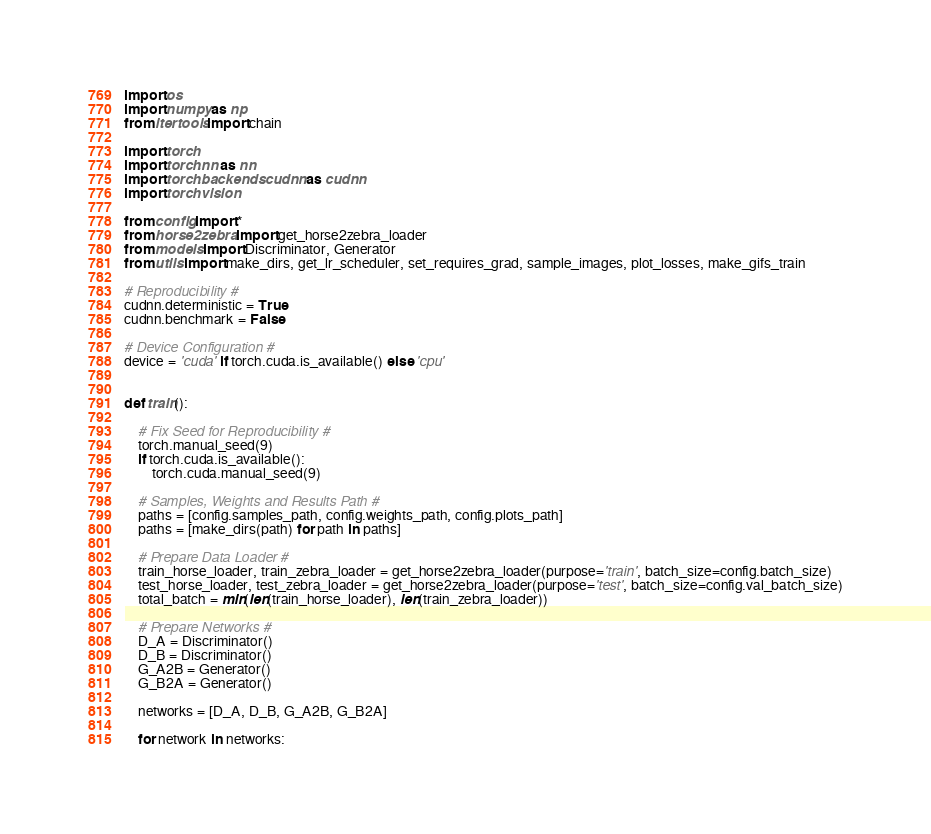<code> <loc_0><loc_0><loc_500><loc_500><_Python_>import os
import numpy as np
from itertools import chain

import torch
import torch.nn as nn
import torch.backends.cudnn as cudnn
import torchvision

from config import *
from horse2zebra import get_horse2zebra_loader
from models import Discriminator, Generator
from utils import make_dirs, get_lr_scheduler, set_requires_grad, sample_images, plot_losses, make_gifs_train

# Reproducibility #
cudnn.deterministic = True
cudnn.benchmark = False

# Device Configuration #
device = 'cuda' if torch.cuda.is_available() else 'cpu'


def train():

    # Fix Seed for Reproducibility #
    torch.manual_seed(9)
    if torch.cuda.is_available():
        torch.cuda.manual_seed(9)

    # Samples, Weights and Results Path #
    paths = [config.samples_path, config.weights_path, config.plots_path]
    paths = [make_dirs(path) for path in paths]

    # Prepare Data Loader #
    train_horse_loader, train_zebra_loader = get_horse2zebra_loader(purpose='train', batch_size=config.batch_size)
    test_horse_loader, test_zebra_loader = get_horse2zebra_loader(purpose='test', batch_size=config.val_batch_size)
    total_batch = min(len(train_horse_loader), len(train_zebra_loader))

    # Prepare Networks #
    D_A = Discriminator()
    D_B = Discriminator()
    G_A2B = Generator()
    G_B2A = Generator()

    networks = [D_A, D_B, G_A2B, G_B2A]

    for network in networks:</code> 